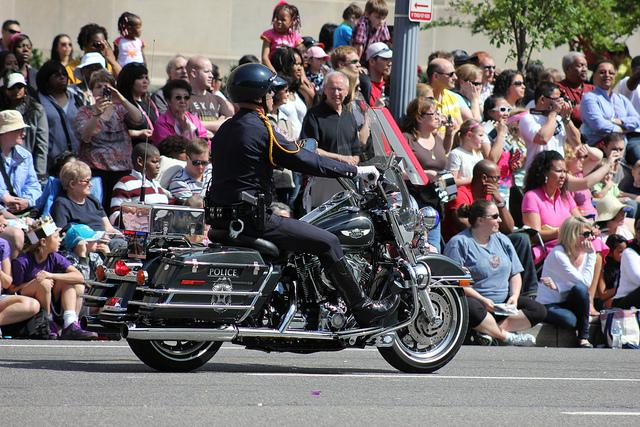Why is the crown worn here? Please explain your reasoning. for fun. The crown is worn just for kicks. 